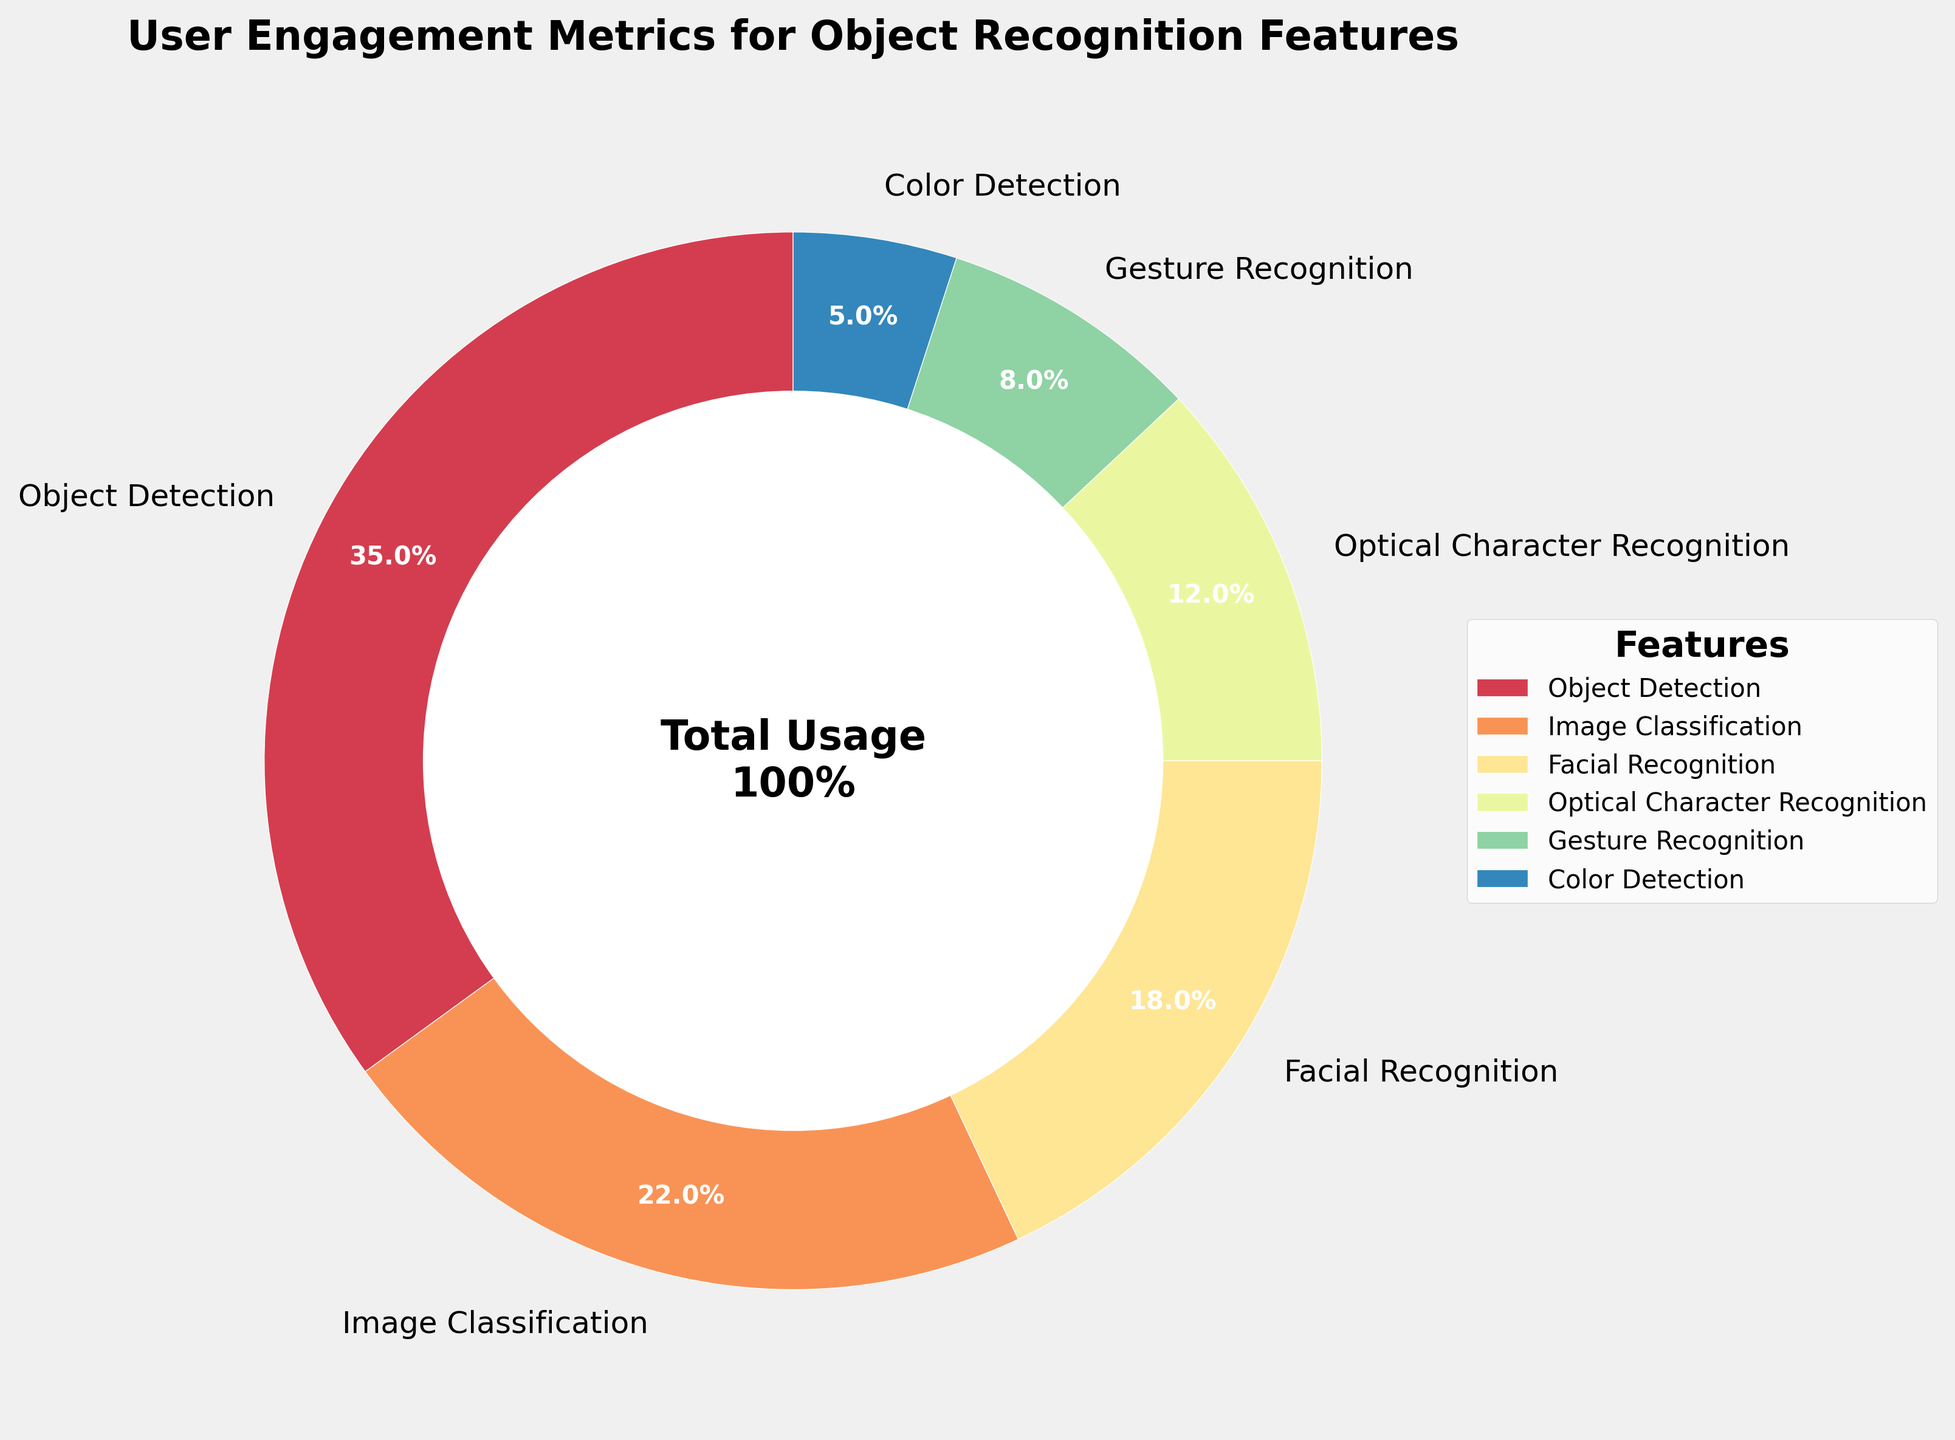what percentage of the user engagement does the Object Detection feature represent? From the pie chart, the slice for Object Detection shows "35%". Thus, the Object Detection feature represents 35% of the total user engagement.
Answer: 35% Which feature has the lowest user engagement percentage? By looking at the pie chart, the smallest slice labeled is "Color Detection," which indicates it has the lowest user engagement percentage, i.e., 5%.
Answer: Color Detection What is the total user engagement percentage for Facial Recognition and Optical Character Recognition combined? The Facial Recognition engagement is 18% and Optical Character Recognition is 12%. Adding them together gives 18% + 12% = 30%.
Answer: 30% Compare the user engagement between Image Classification and Gesture Recognition. From the pie chart, Image Classification shows 22% user engagement, while Gesture Recognition shows 8%. Hence, Image Classification has a higher user engagement compared to Gesture Recognition.
Answer: Image Classification How much more user engagement does Object Detection have compared to Gesture Recognition? Object Detection has a 35% user engagement, and Gesture Recognition has 8%. The difference is 35% - 8% = 27%.
Answer: 27% Which feature has the second highest user engagement? From the pie chart, Object Detection has the highest user engagement at 35%. The next largest slice is Image Classification at 22%. Hence, Image Classification has the second highest user engagement.
Answer: Image Classification If the user engagement percentages were to change so that each of the top three features were equal, what would their new percentage each be? The top three features are Object Detection (35%), Image Classification (22%), and Facial Recognition (18%). Their total percentage is 35% + 22% + 18% = 75%. If equally divided, each would be 75% / 3 = 25%.
Answer: 25% Are there more features with user engagement percentages above or below 10%? From the pie chart, the features with above 10% engagement are Object Detection (35%), Image Classification (22%), Facial Recognition (18%), and Optical Character Recognition (12%)—a total of 4 features. The features below 10% are Gesture Recognition (8%) and Color Detection (5%)—a total of 2 features. There are more features above 10%.
Answer: Above 